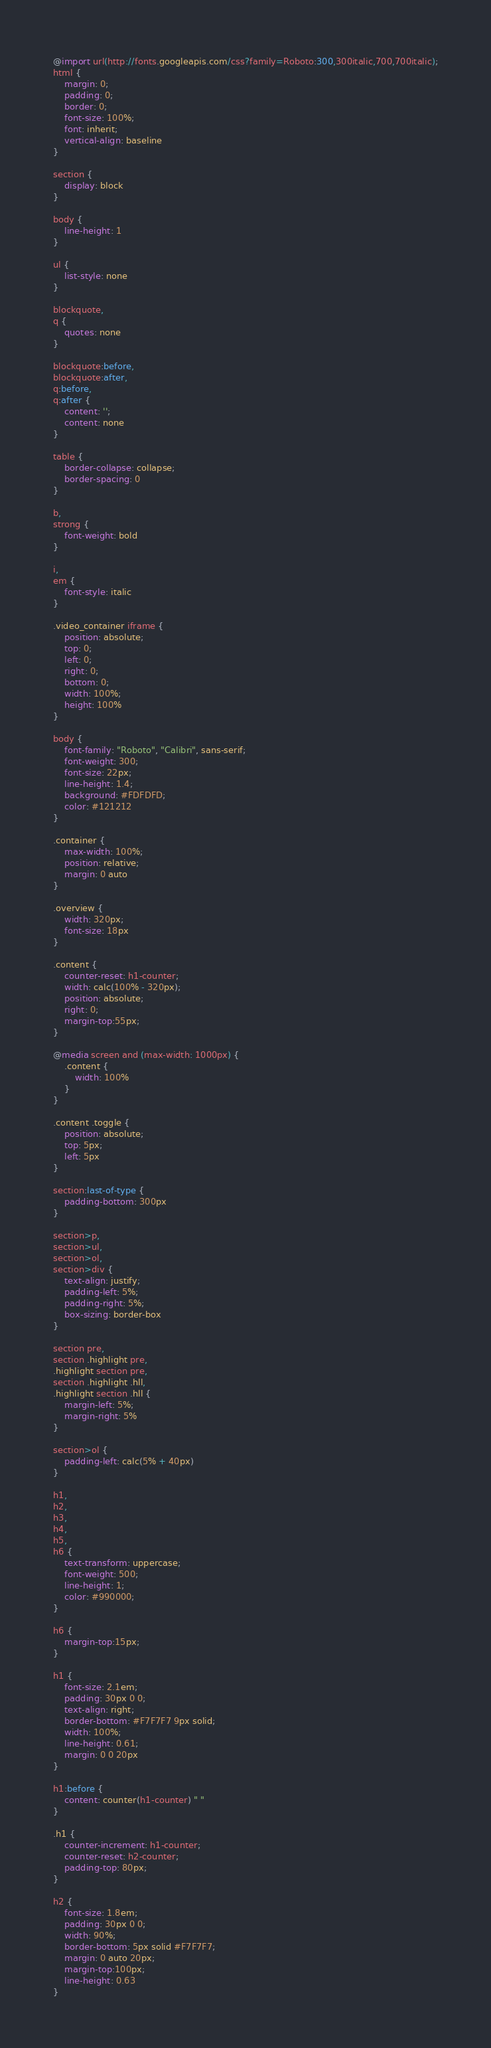<code> <loc_0><loc_0><loc_500><loc_500><_CSS_>@import url(http://fonts.googleapis.com/css?family=Roboto:300,300italic,700,700italic);
html {
    margin: 0;
    padding: 0;
    border: 0;
    font-size: 100%;
    font: inherit;
    vertical-align: baseline
}

section {
    display: block
}

body {
    line-height: 1
}

ul {
    list-style: none
}

blockquote,
q {
    quotes: none
}

blockquote:before,
blockquote:after,
q:before,
q:after {
    content: '';
    content: none
}

table {
    border-collapse: collapse;
    border-spacing: 0
}

b,
strong {
    font-weight: bold
}

i,
em {
    font-style: italic
}

.video_container iframe {
    position: absolute;
    top: 0;
    left: 0;
    right: 0;
    bottom: 0;
    width: 100%;
    height: 100%
}

body {
    font-family: "Roboto", "Calibri", sans-serif;
    font-weight: 300;
    font-size: 22px;
    line-height: 1.4;
    background: #FDFDFD;
    color: #121212
}

.container {
    max-width: 100%;
    position: relative;
    margin: 0 auto
}

.overview {
    width: 320px;
    font-size: 18px
}

.content {
    counter-reset: h1-counter;
    width: calc(100% - 320px);
    position: absolute;
    right: 0;
    margin-top:55px;
}

@media screen and (max-width: 1000px) {
    .content {
        width: 100%
    }
}

.content .toggle {
    position: absolute;
    top: 5px;
    left: 5px
}

section:last-of-type {
    padding-bottom: 300px
}

section>p,
section>ul,
section>ol,
section>div {
    text-align: justify;
    padding-left: 5%;
    padding-right: 5%;
    box-sizing: border-box
}

section pre,
section .highlight pre,
.highlight section pre,
section .highlight .hll,
.highlight section .hll {
    margin-left: 5%;
    margin-right: 5%
}

section>ol {
    padding-left: calc(5% + 40px)
}

h1,
h2,
h3,
h4,
h5,
h6 {
    text-transform: uppercase;
    font-weight: 500;
    line-height: 1;
    color: #990000;
}

h6 {
    margin-top:15px;
}

h1 {
    font-size: 2.1em;
    padding: 30px 0 0;
    text-align: right;
    border-bottom: #F7F7F7 9px solid;
    width: 100%;
    line-height: 0.61;
    margin: 0 0 20px
}

h1:before {
    content: counter(h1-counter) " "
}

.h1 {
    counter-increment: h1-counter;
    counter-reset: h2-counter;
    padding-top: 80px;
}

h2 {
    font-size: 1.8em;
    padding: 30px 0 0;
    width: 90%;
    border-bottom: 5px solid #F7F7F7;
    margin: 0 auto 20px;
    margin-top:100px;
    line-height: 0.63
}
</code> 